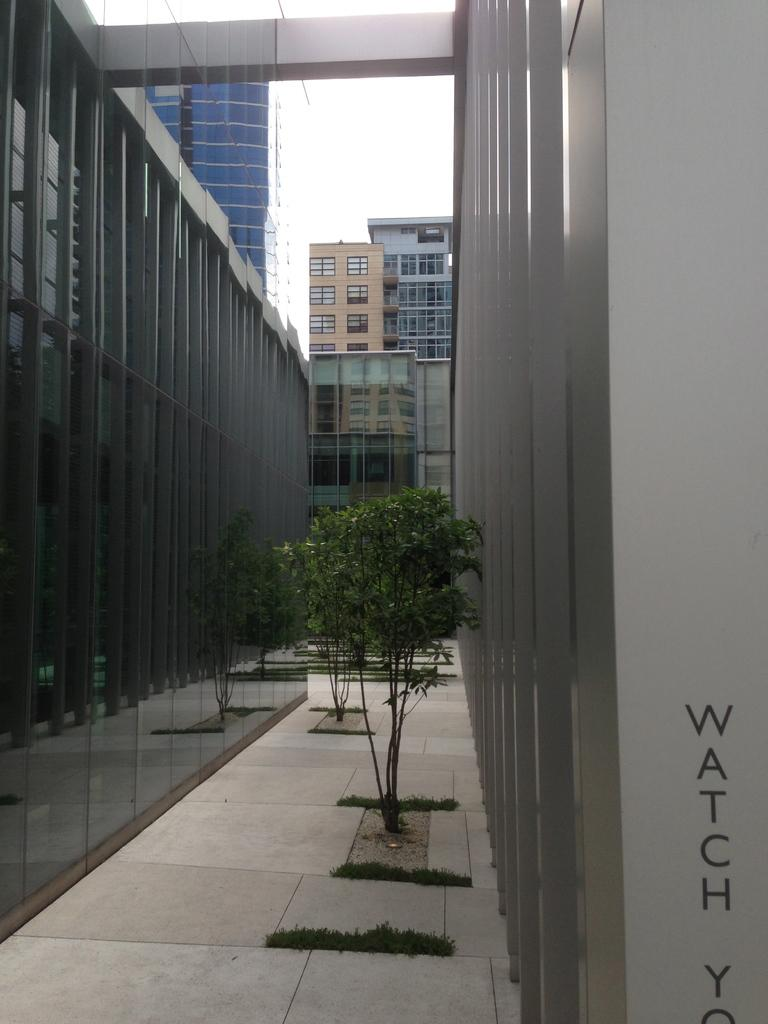What is the main subject in the middle of the image? There is a plant in the middle of the image. What can be seen surrounding the plant? There are buildings around the plant. What type of protest is happening near the plant in the image? There is no protest visible in the image; it only features a plant and buildings. What color is the sweater worn by the plant in the image? Plants do not wear sweaters, so this question cannot be answered. 